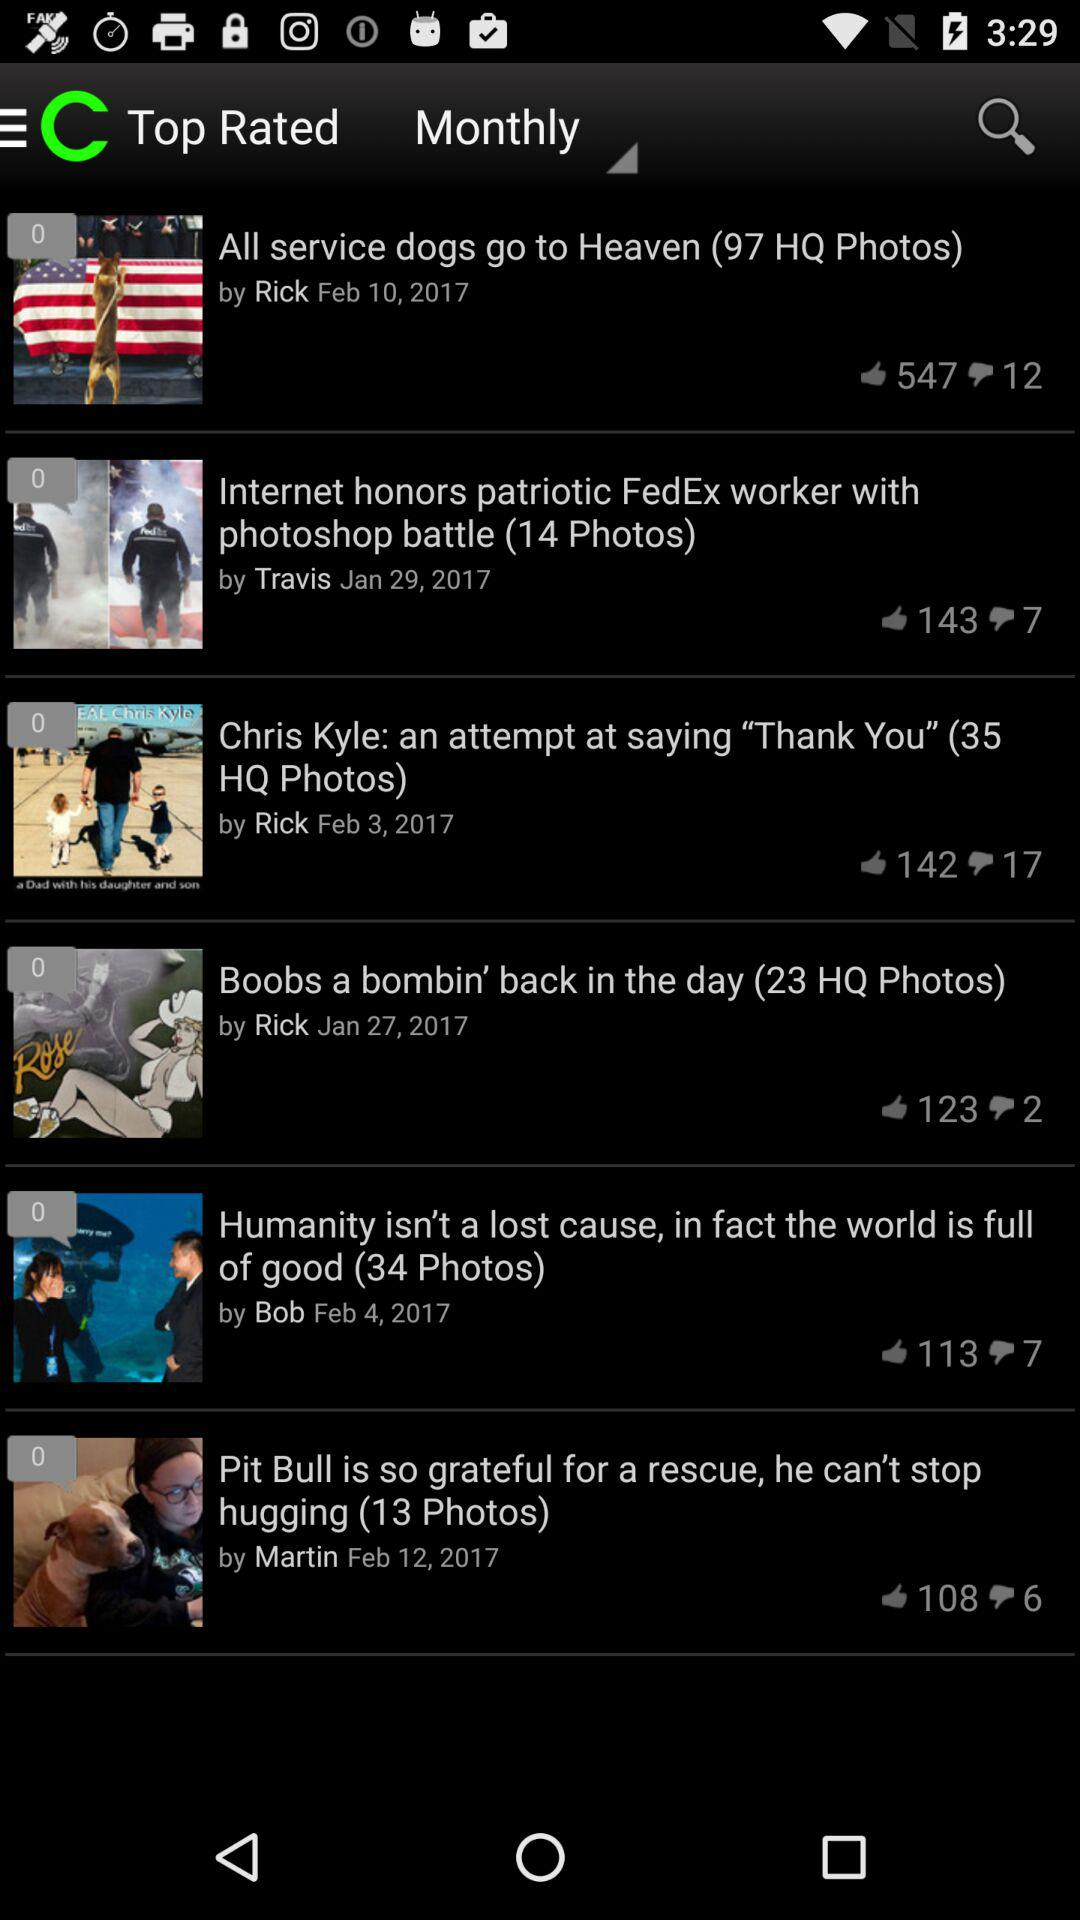What is the heading of the news posted by Bob? The heading of the news is "Humanity isn't a lost cause, in fact the world is full of good (34 Photos)". 